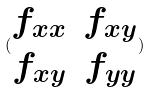Convert formula to latex. <formula><loc_0><loc_0><loc_500><loc_500>( \begin{matrix} f _ { x x } & f _ { x y } \\ f _ { x y } & f _ { y y } \end{matrix} )</formula> 